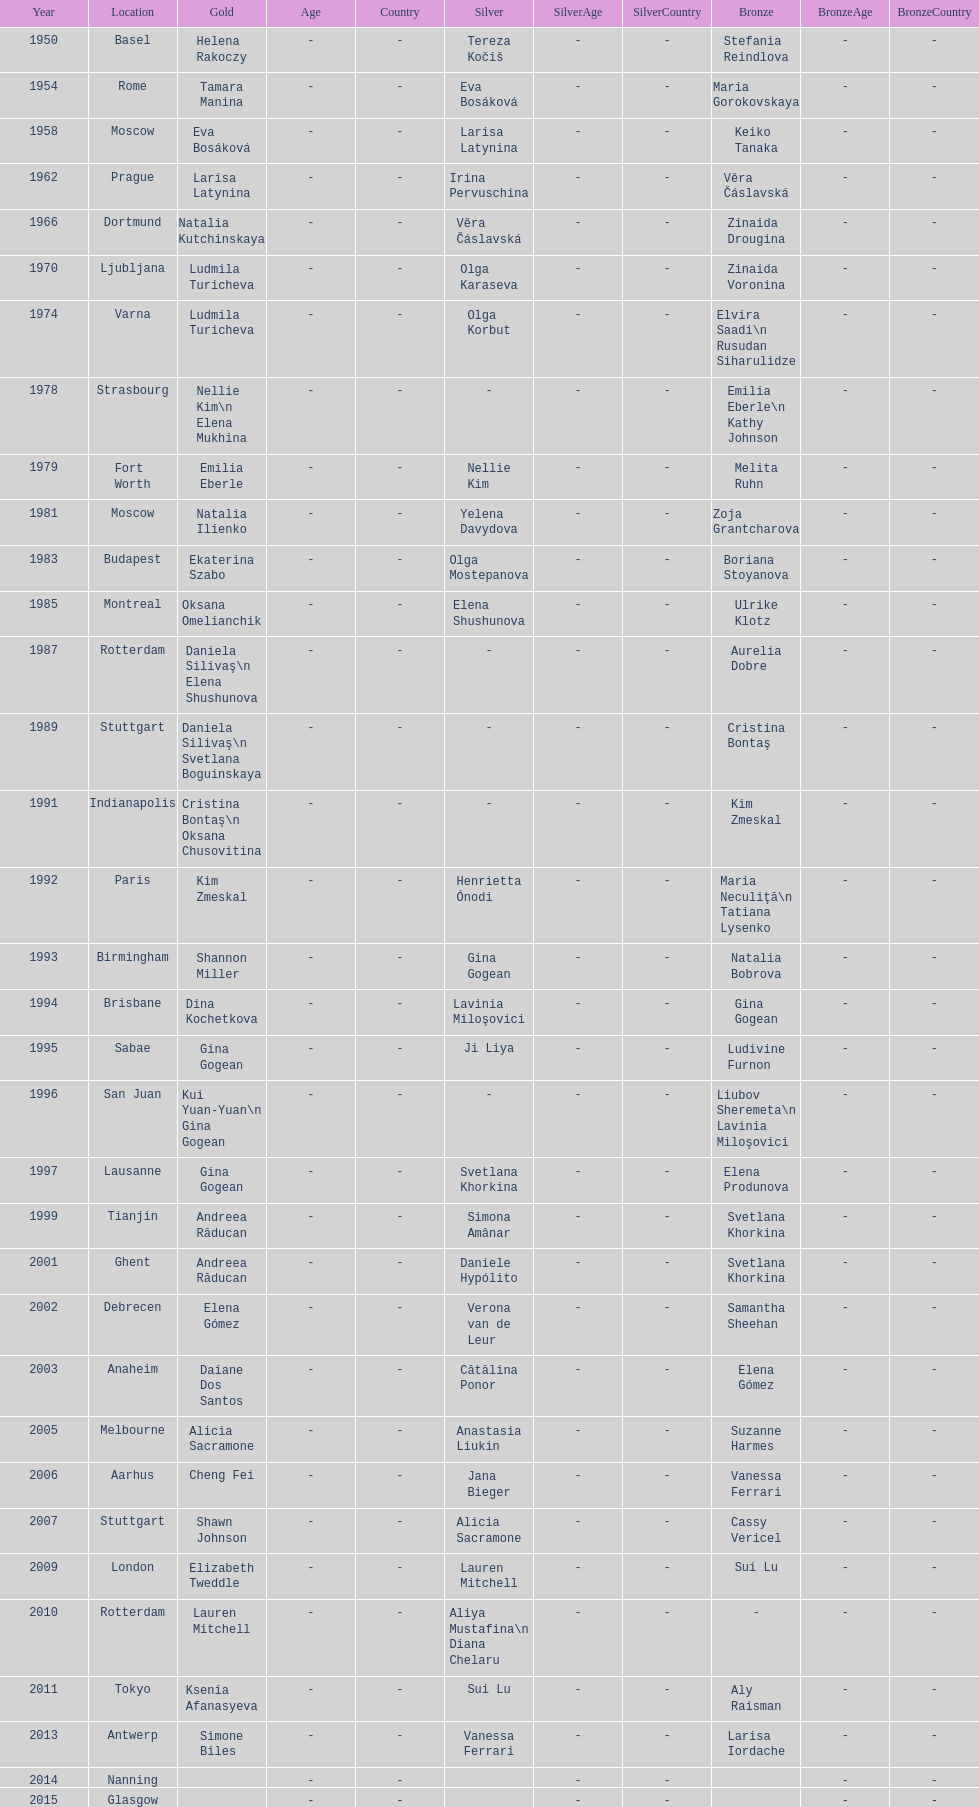Where did the world artistic gymnastics take place before san juan? Sabae. 